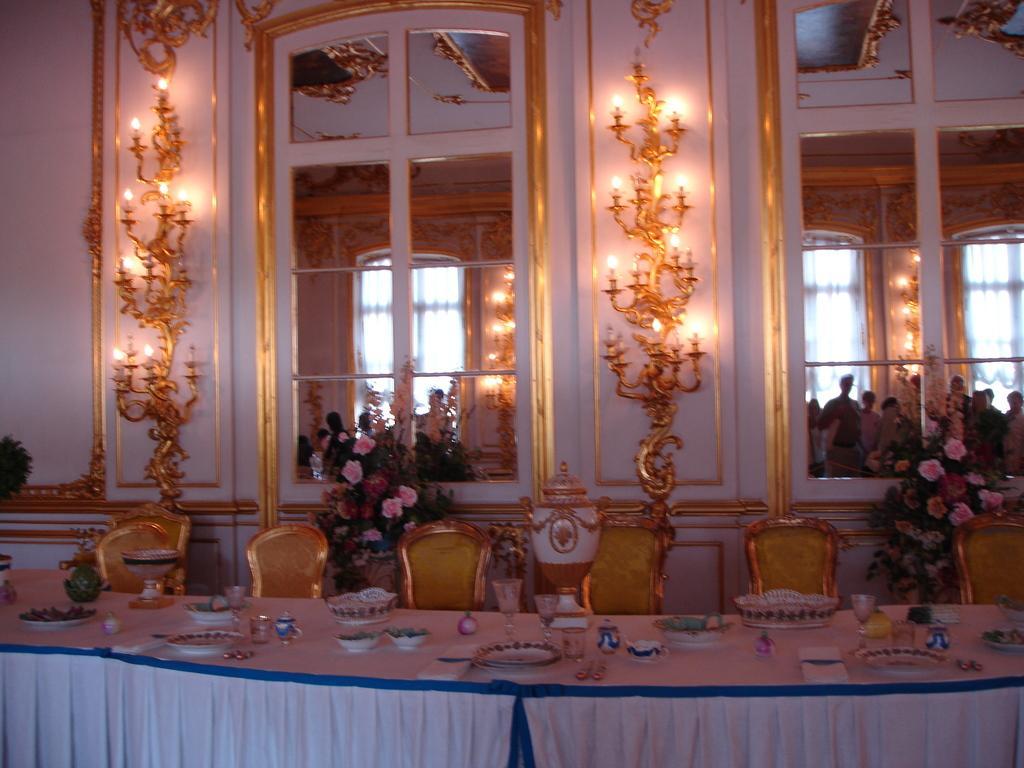Could you give a brief overview of what you see in this image? It is a big dining table, there are plates and wine glasses on it. These are the chairs, these are the two glass windows. There are lights on the wall. 